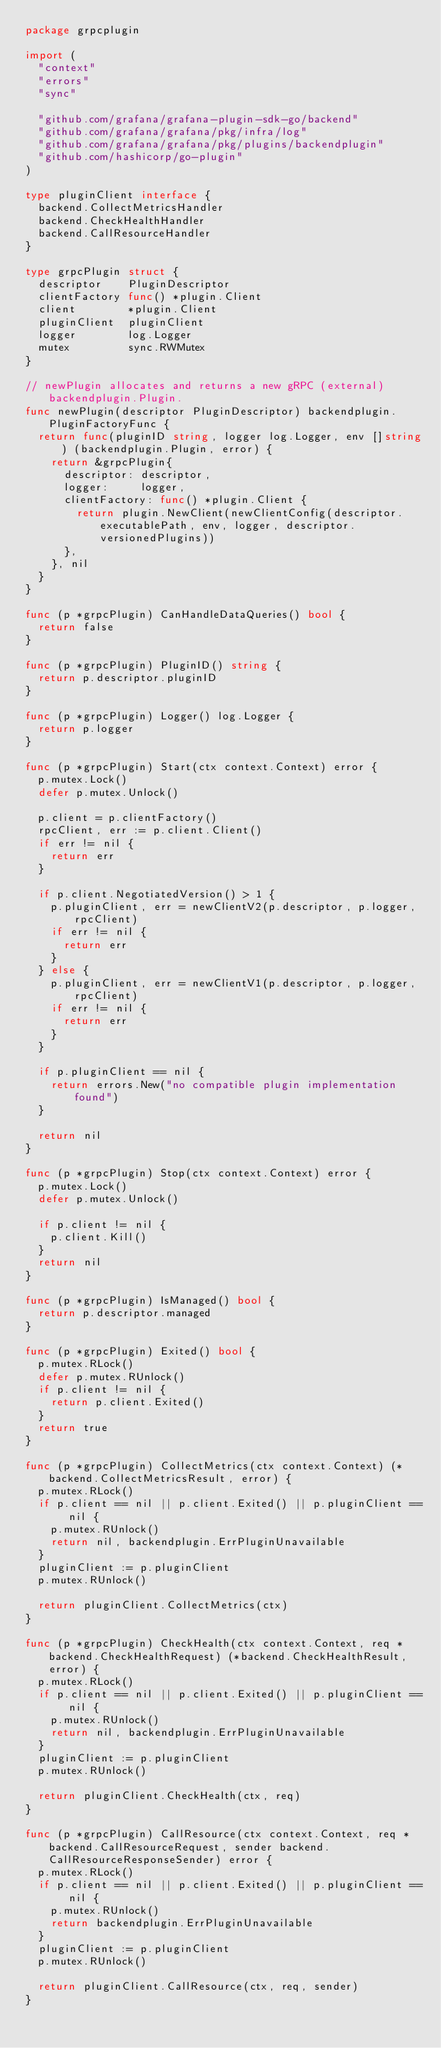Convert code to text. <code><loc_0><loc_0><loc_500><loc_500><_Go_>package grpcplugin

import (
	"context"
	"errors"
	"sync"

	"github.com/grafana/grafana-plugin-sdk-go/backend"
	"github.com/grafana/grafana/pkg/infra/log"
	"github.com/grafana/grafana/pkg/plugins/backendplugin"
	"github.com/hashicorp/go-plugin"
)

type pluginClient interface {
	backend.CollectMetricsHandler
	backend.CheckHealthHandler
	backend.CallResourceHandler
}

type grpcPlugin struct {
	descriptor    PluginDescriptor
	clientFactory func() *plugin.Client
	client        *plugin.Client
	pluginClient  pluginClient
	logger        log.Logger
	mutex         sync.RWMutex
}

// newPlugin allocates and returns a new gRPC (external) backendplugin.Plugin.
func newPlugin(descriptor PluginDescriptor) backendplugin.PluginFactoryFunc {
	return func(pluginID string, logger log.Logger, env []string) (backendplugin.Plugin, error) {
		return &grpcPlugin{
			descriptor: descriptor,
			logger:     logger,
			clientFactory: func() *plugin.Client {
				return plugin.NewClient(newClientConfig(descriptor.executablePath, env, logger, descriptor.versionedPlugins))
			},
		}, nil
	}
}

func (p *grpcPlugin) CanHandleDataQueries() bool {
	return false
}

func (p *grpcPlugin) PluginID() string {
	return p.descriptor.pluginID
}

func (p *grpcPlugin) Logger() log.Logger {
	return p.logger
}

func (p *grpcPlugin) Start(ctx context.Context) error {
	p.mutex.Lock()
	defer p.mutex.Unlock()

	p.client = p.clientFactory()
	rpcClient, err := p.client.Client()
	if err != nil {
		return err
	}

	if p.client.NegotiatedVersion() > 1 {
		p.pluginClient, err = newClientV2(p.descriptor, p.logger, rpcClient)
		if err != nil {
			return err
		}
	} else {
		p.pluginClient, err = newClientV1(p.descriptor, p.logger, rpcClient)
		if err != nil {
			return err
		}
	}

	if p.pluginClient == nil {
		return errors.New("no compatible plugin implementation found")
	}

	return nil
}

func (p *grpcPlugin) Stop(ctx context.Context) error {
	p.mutex.Lock()
	defer p.mutex.Unlock()

	if p.client != nil {
		p.client.Kill()
	}
	return nil
}

func (p *grpcPlugin) IsManaged() bool {
	return p.descriptor.managed
}

func (p *grpcPlugin) Exited() bool {
	p.mutex.RLock()
	defer p.mutex.RUnlock()
	if p.client != nil {
		return p.client.Exited()
	}
	return true
}

func (p *grpcPlugin) CollectMetrics(ctx context.Context) (*backend.CollectMetricsResult, error) {
	p.mutex.RLock()
	if p.client == nil || p.client.Exited() || p.pluginClient == nil {
		p.mutex.RUnlock()
		return nil, backendplugin.ErrPluginUnavailable
	}
	pluginClient := p.pluginClient
	p.mutex.RUnlock()

	return pluginClient.CollectMetrics(ctx)
}

func (p *grpcPlugin) CheckHealth(ctx context.Context, req *backend.CheckHealthRequest) (*backend.CheckHealthResult, error) {
	p.mutex.RLock()
	if p.client == nil || p.client.Exited() || p.pluginClient == nil {
		p.mutex.RUnlock()
		return nil, backendplugin.ErrPluginUnavailable
	}
	pluginClient := p.pluginClient
	p.mutex.RUnlock()

	return pluginClient.CheckHealth(ctx, req)
}

func (p *grpcPlugin) CallResource(ctx context.Context, req *backend.CallResourceRequest, sender backend.CallResourceResponseSender) error {
	p.mutex.RLock()
	if p.client == nil || p.client.Exited() || p.pluginClient == nil {
		p.mutex.RUnlock()
		return backendplugin.ErrPluginUnavailable
	}
	pluginClient := p.pluginClient
	p.mutex.RUnlock()

	return pluginClient.CallResource(ctx, req, sender)
}
</code> 